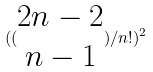Convert formula to latex. <formula><loc_0><loc_0><loc_500><loc_500>( ( \begin{matrix} 2 n - 2 \\ n - 1 \end{matrix} ) / n ! ) ^ { 2 }</formula> 